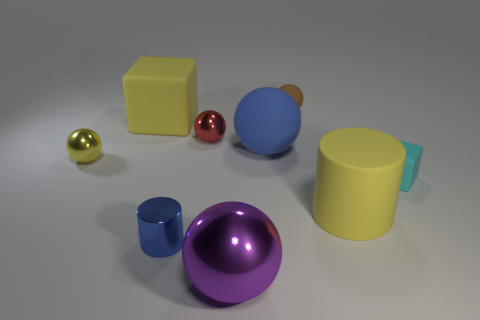What size is the cylinder that is the same material as the purple sphere?
Provide a succinct answer. Small. There is a cyan rubber thing; is it the same shape as the large yellow object that is on the left side of the yellow cylinder?
Your answer should be very brief. Yes. What is the size of the red metal sphere?
Keep it short and to the point. Small. Is the number of small yellow shiny objects in front of the tiny block less than the number of large balls?
Give a very brief answer. Yes. How many cyan metallic cylinders are the same size as the brown sphere?
Provide a succinct answer. 0. What is the shape of the big object that is the same color as the matte cylinder?
Provide a succinct answer. Cube. There is a tiny thing in front of the cyan cube; is its color the same as the block behind the yellow metal object?
Offer a very short reply. No. There is a red object; what number of large purple shiny things are behind it?
Your answer should be very brief. 0. What is the size of the rubber thing that is the same color as the metal cylinder?
Offer a terse response. Large. Is there another big matte thing of the same shape as the big blue matte thing?
Offer a very short reply. No. 